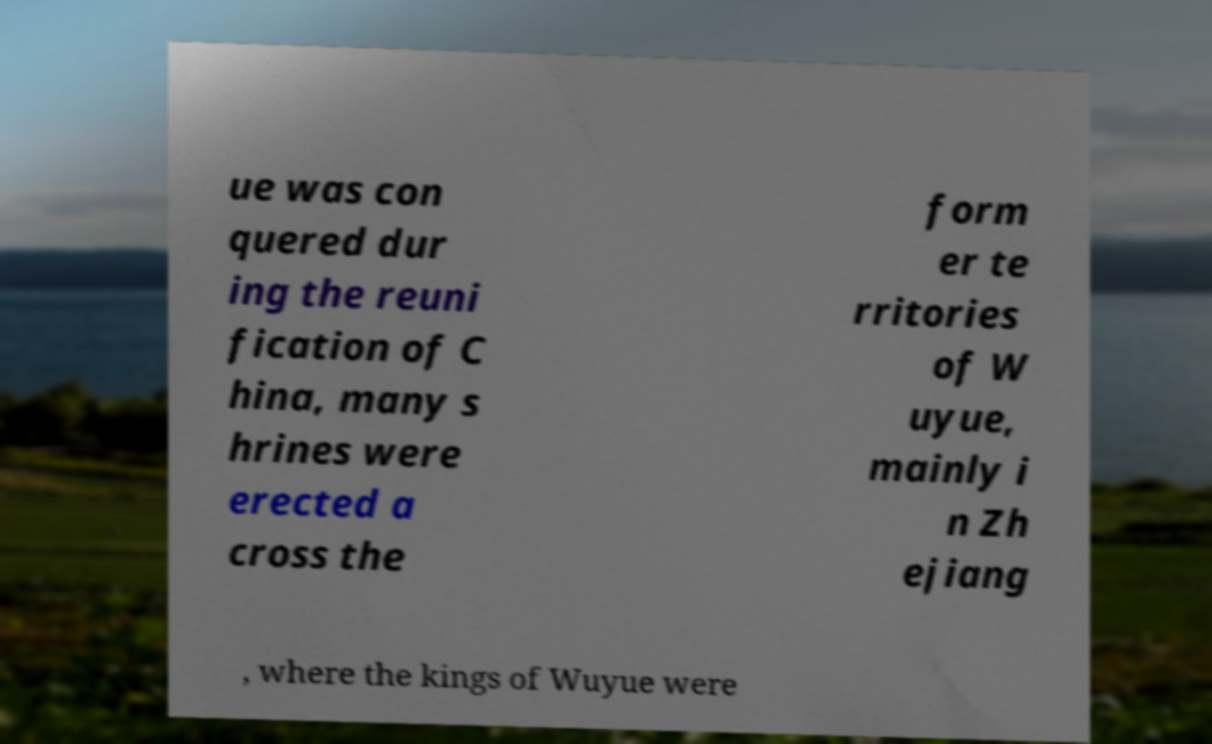Please read and relay the text visible in this image. What does it say? ue was con quered dur ing the reuni fication of C hina, many s hrines were erected a cross the form er te rritories of W uyue, mainly i n Zh ejiang , where the kings of Wuyue were 